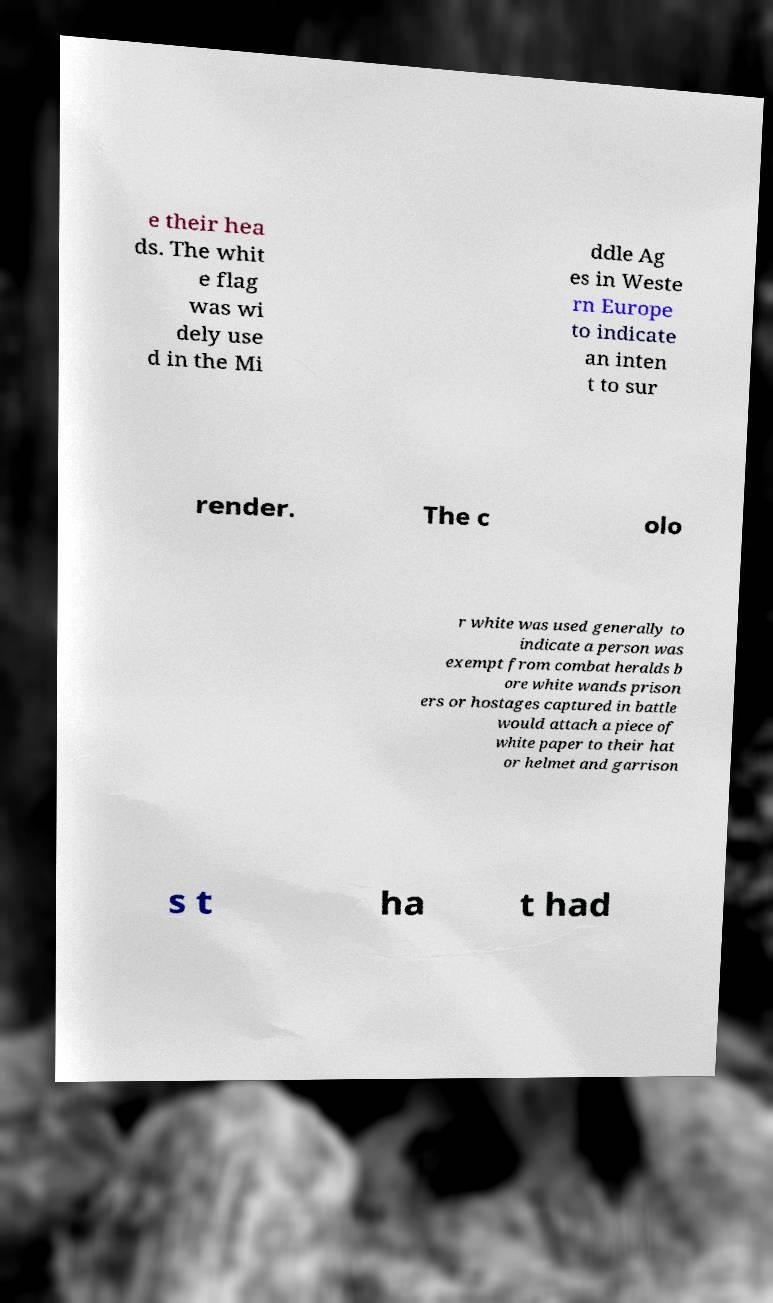Please read and relay the text visible in this image. What does it say? e their hea ds. The whit e flag was wi dely use d in the Mi ddle Ag es in Weste rn Europe to indicate an inten t to sur render. The c olo r white was used generally to indicate a person was exempt from combat heralds b ore white wands prison ers or hostages captured in battle would attach a piece of white paper to their hat or helmet and garrison s t ha t had 